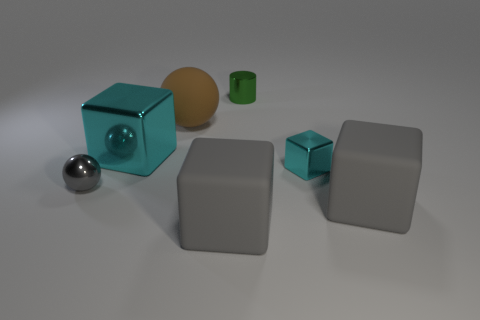Can you tell me about the lighting in the scene? The lighting in the scene is diffused, creating soft shadows under the objects. It appears to be coming from above, possibly from a single source, as indicated by the consistent direction of the shadows. 